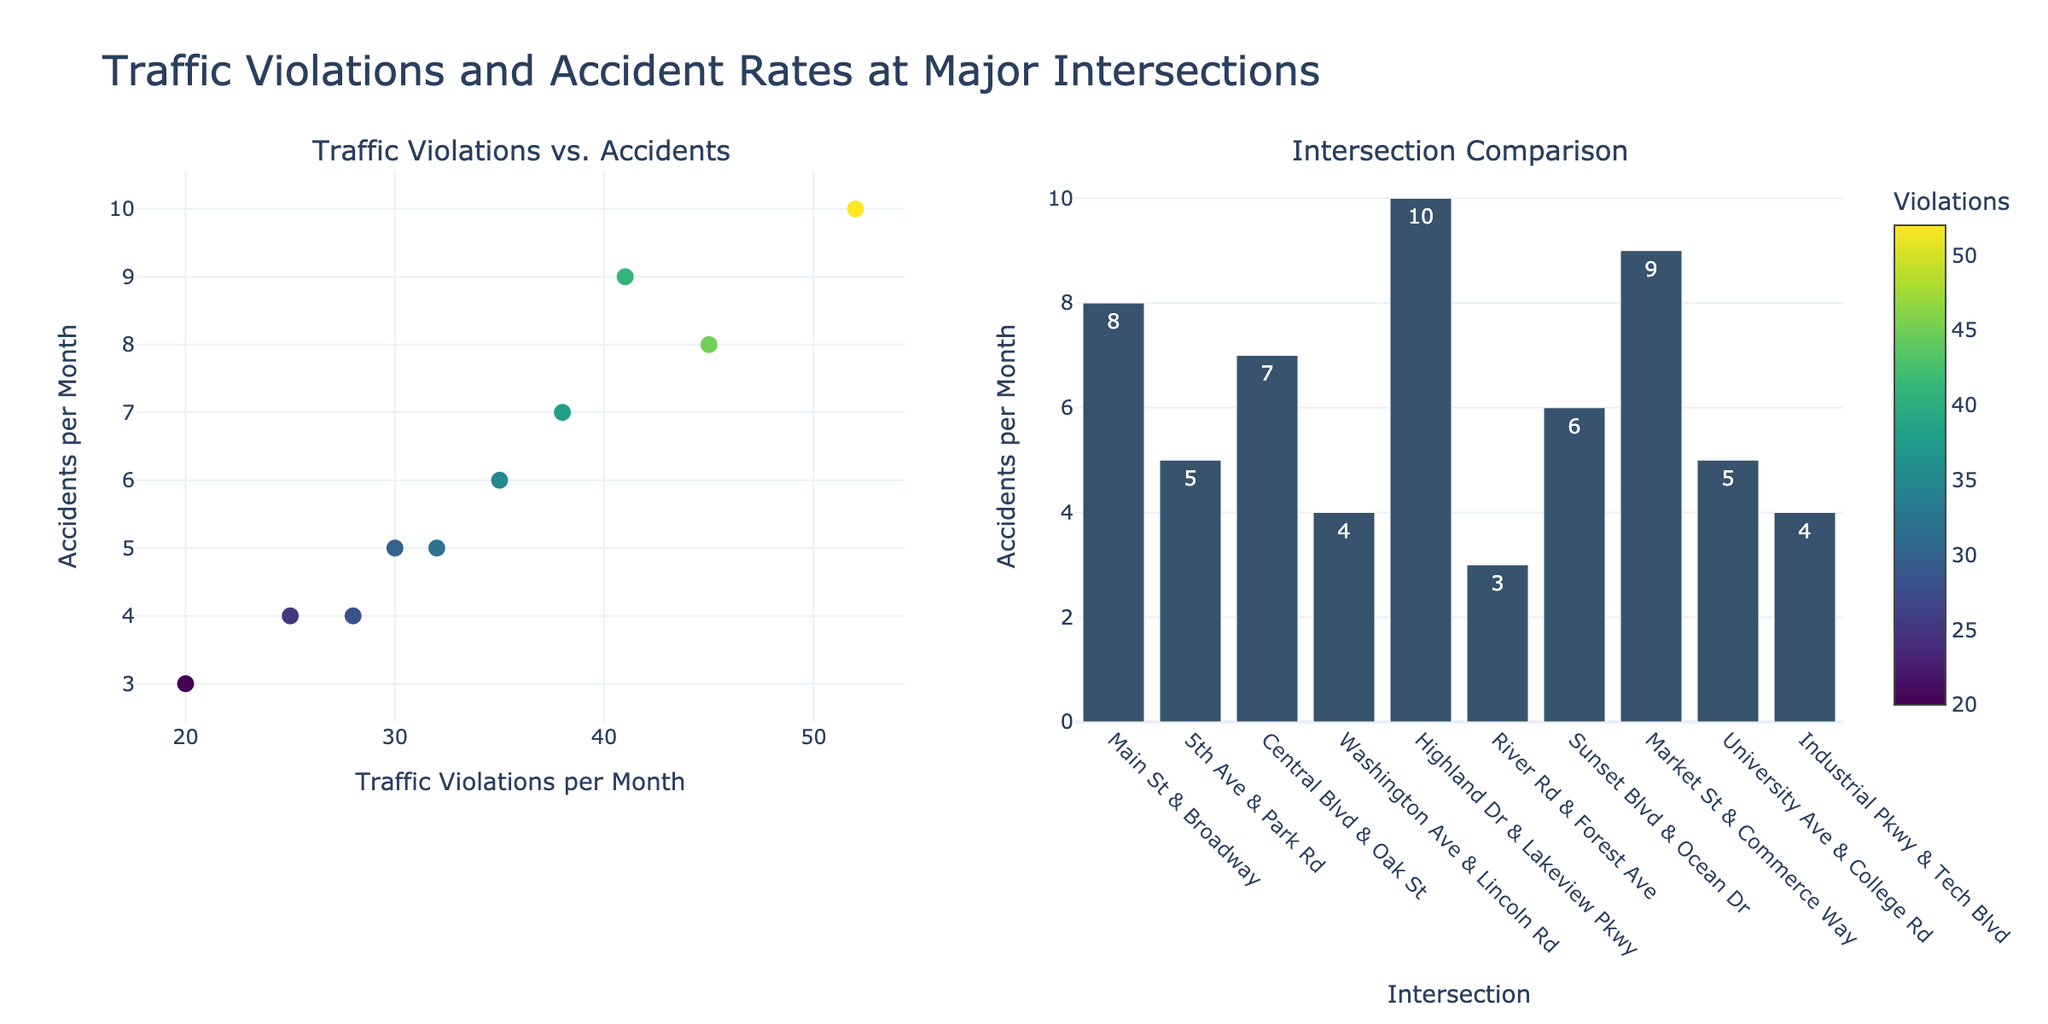What is the title of the figure? The title of the figure is a text element located above the plots. It summarizes the overall theme of the data presented. In this case, the title is clearly presented at the top center of the figure.
Answer: Match-Fixing Incidents in Major Sports Leagues (2013-2022) Which league had the most match-fixing incidents in 2015? To determine the league with the most match-fixing incidents in 2015, we look at the data points for all leagues in the subplot corresponding to 2015 and compare the values.
Answer: Premier League Between which years did the NBA experience its highest increase in match-fixing incidents? To find this, observe the NBA subplot and look for the steepest upward line segment; this indicates the largest increase. The years before and after this line segment are the years of interest.
Answer: 2015 to 2016 What was the total number of match-fixing incidents reported across all leagues in 2014? For this, sum the values of match-fixing incidents for all leagues in the year 2014.
Answer: 11 Which leagues showed a decreasing trend in match-fixing incidents between 2019 and 2020? Observe the subplots for all leagues and identify those with a line segment that slopes downward between the years 2019 and 2020.
Answer: NFL, MLB, La Liga Which year has the highest reported incidents for La Liga and how many incidents were there? Check the La Liga subplot and identify the highest data point along the y-axis and note the corresponding year.
Answer: 2016, 4 What is the average number of match-fixing incidents in the NFL over the given decade? To calculate the average, sum the total incidents in the NFL over the years and divide by the number of years (10).
Answer: 2.3 How many sports leagues recorded exactly 3 match-fixing incidents in 2018? Look at the data points for 2018 across all subplots and count how many are equal to 3.
Answer: 2 Which league shows the most fluctuation in match-fixing incidents over the period? Fluctuation can be determined by observing the variability in the data points of each league's subplot. The league with the most up and down movements shows the most fluctuation.
Answer: NBA In which years did the Premier League have 4 match-fixing incidents? Identify the data points in the Premier League subplot where the y-value equals 4 and note the corresponding years.
Answer: 2013, 2018 